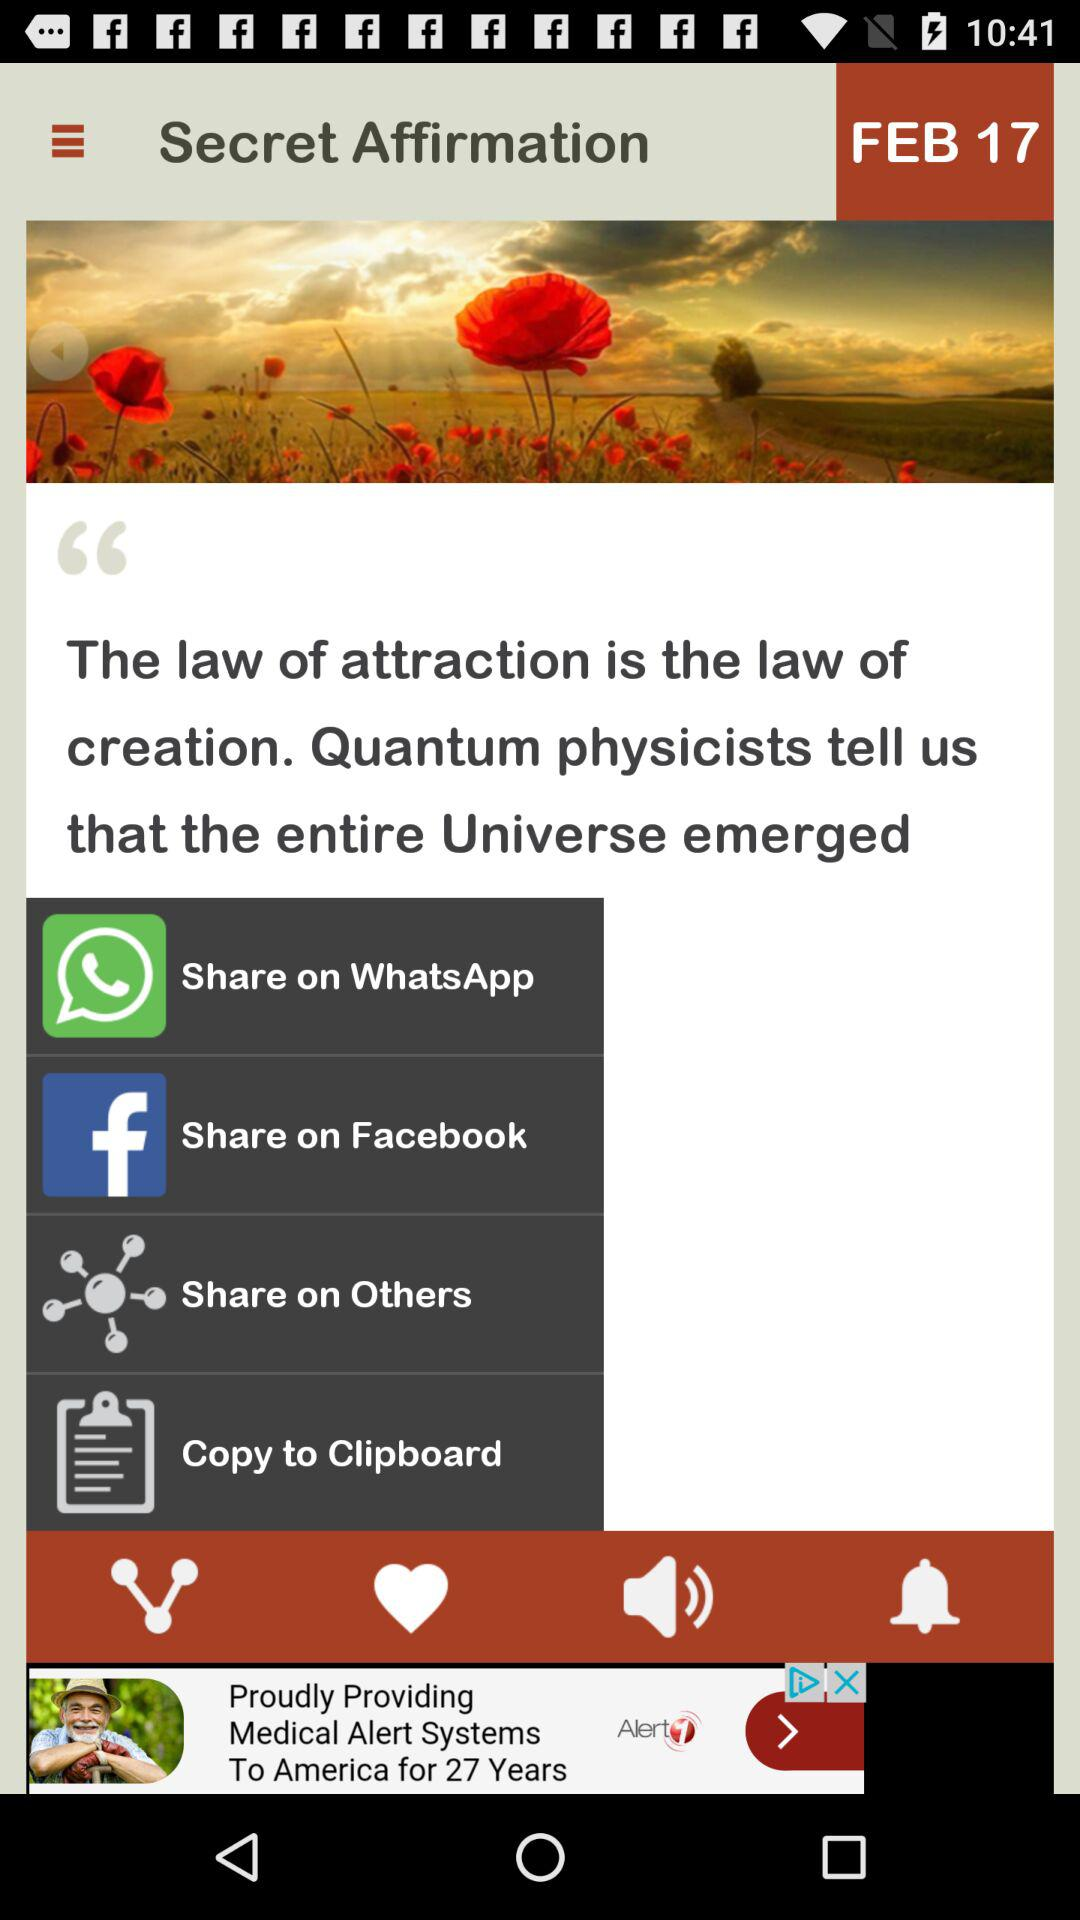What options are available to share? The options are "WhatsApp", "Facebook" and "Others". 